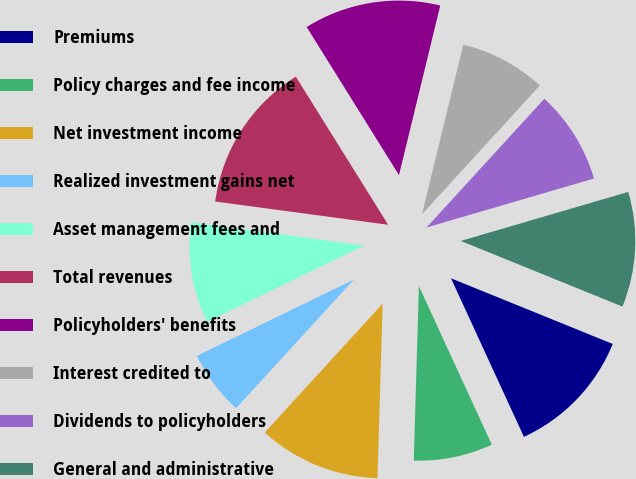Convert chart. <chart><loc_0><loc_0><loc_500><loc_500><pie_chart><fcel>Premiums<fcel>Policy charges and fee income<fcel>Net investment income<fcel>Realized investment gains net<fcel>Asset management fees and<fcel>Total revenues<fcel>Policyholders' benefits<fcel>Interest credited to<fcel>Dividends to policyholders<fcel>General and administrative<nl><fcel>12.0%<fcel>7.33%<fcel>11.33%<fcel>6.0%<fcel>9.33%<fcel>14.0%<fcel>12.67%<fcel>8.0%<fcel>8.67%<fcel>10.67%<nl></chart> 